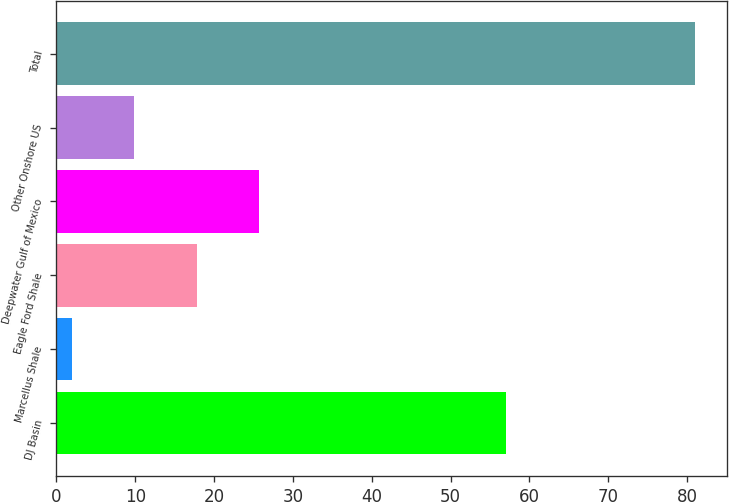Convert chart. <chart><loc_0><loc_0><loc_500><loc_500><bar_chart><fcel>DJ Basin<fcel>Marcellus Shale<fcel>Eagle Ford Shale<fcel>Deepwater Gulf of Mexico<fcel>Other Onshore US<fcel>Total<nl><fcel>57<fcel>2<fcel>17.8<fcel>25.7<fcel>9.9<fcel>81<nl></chart> 